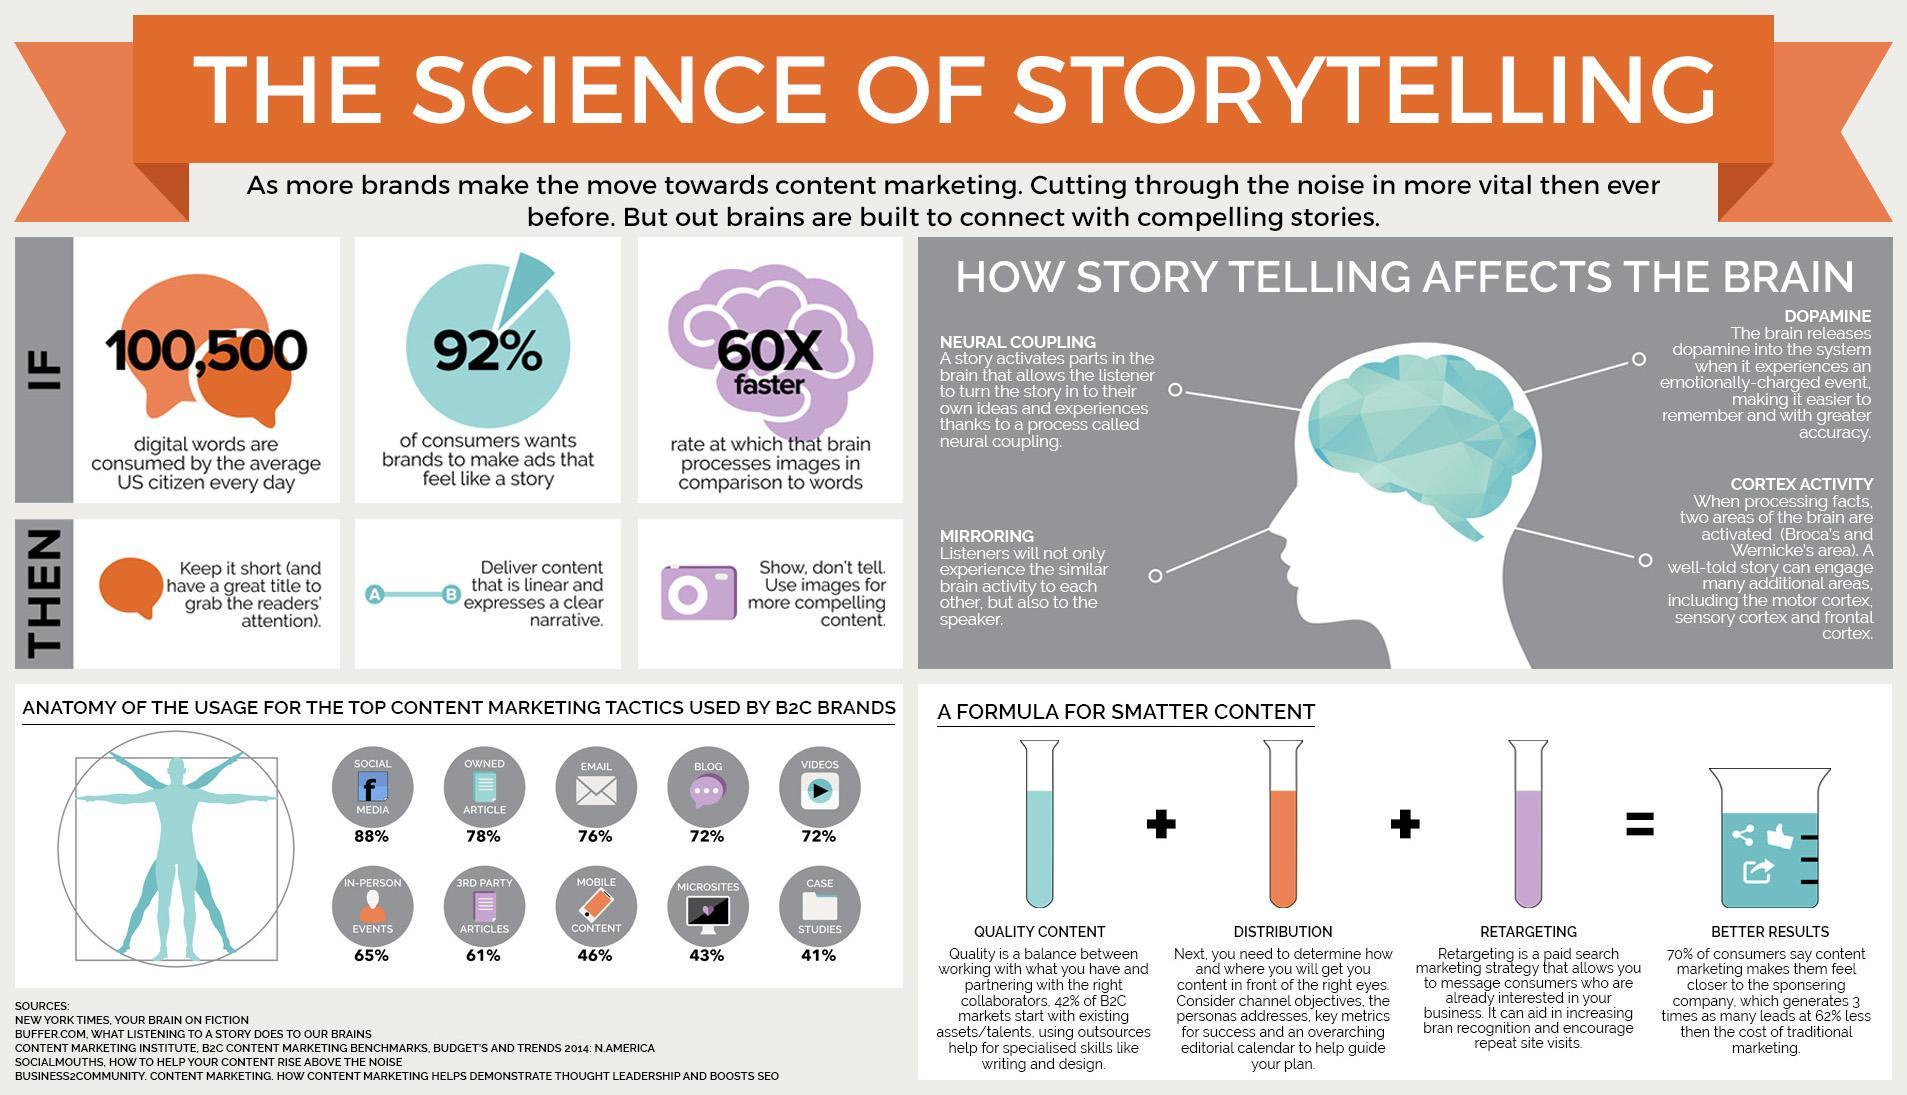What is the percentage of Mobile Content?
Answer the question with a short phrase. 46% How many ways does storytelling affect the brain? 4 What are the factors that result in better content? Quality Content, Distribution, Retargeting What is the percentage of Email usage? 76% What is the percentage of Video usage? 72% 